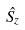<formula> <loc_0><loc_0><loc_500><loc_500>\hat { S _ { z } }</formula> 